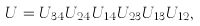Convert formula to latex. <formula><loc_0><loc_0><loc_500><loc_500>U = U _ { 3 4 } U _ { 2 4 } U _ { 1 4 } U _ { 2 3 } U _ { 1 3 } U _ { 1 2 } ,</formula> 